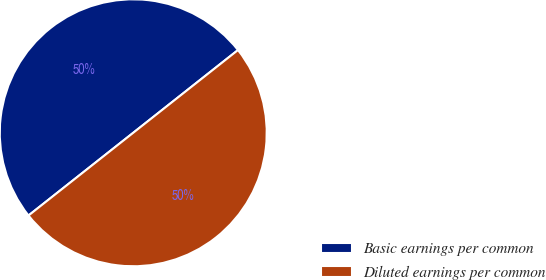Convert chart to OTSL. <chart><loc_0><loc_0><loc_500><loc_500><pie_chart><fcel>Basic earnings per common<fcel>Diluted earnings per common<nl><fcel>50.0%<fcel>50.0%<nl></chart> 